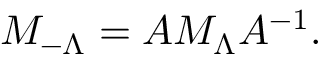<formula> <loc_0><loc_0><loc_500><loc_500>M _ { - \Lambda } = A M _ { \Lambda } A ^ { - 1 } .</formula> 